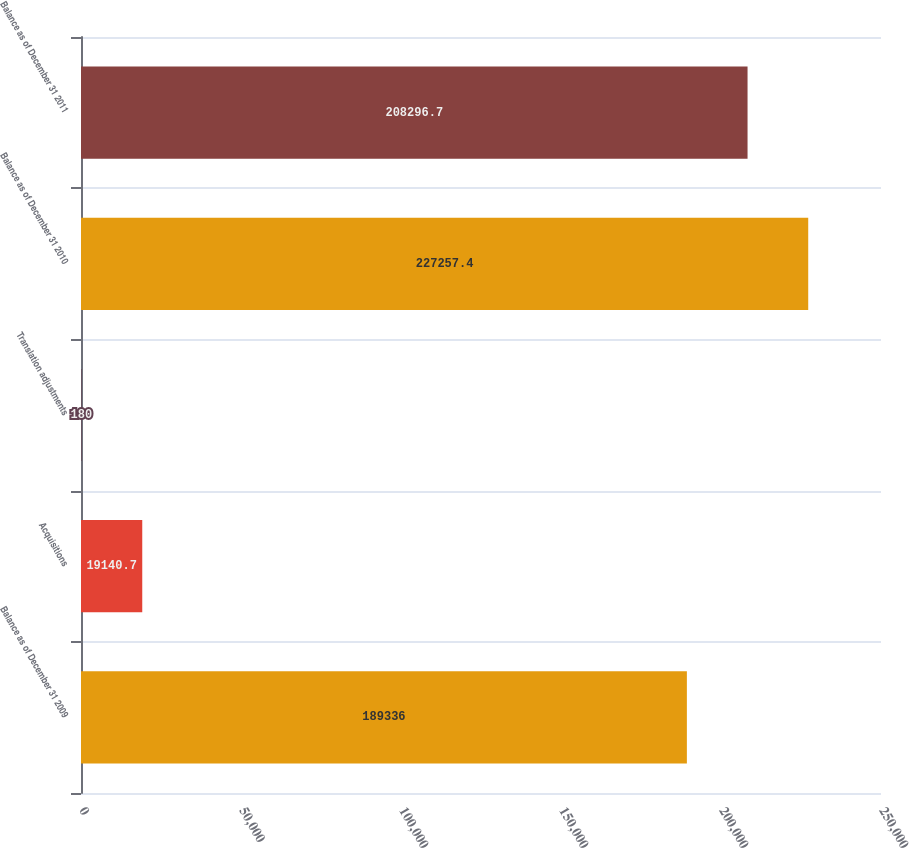Convert chart. <chart><loc_0><loc_0><loc_500><loc_500><bar_chart><fcel>Balance as of December 31 2009<fcel>Acquisitions<fcel>Translation adjustments<fcel>Balance as of December 31 2010<fcel>Balance as of December 31 2011<nl><fcel>189336<fcel>19140.7<fcel>180<fcel>227257<fcel>208297<nl></chart> 